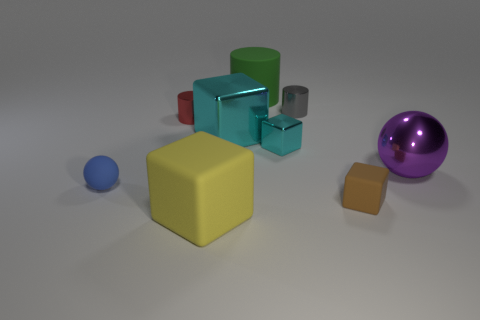Subtract 1 cubes. How many cubes are left? 3 Add 1 red shiny cylinders. How many objects exist? 10 Subtract all spheres. How many objects are left? 7 Subtract all gray things. Subtract all large objects. How many objects are left? 4 Add 5 big cyan shiny things. How many big cyan shiny things are left? 6 Add 1 rubber cubes. How many rubber cubes exist? 3 Subtract 0 brown cylinders. How many objects are left? 9 